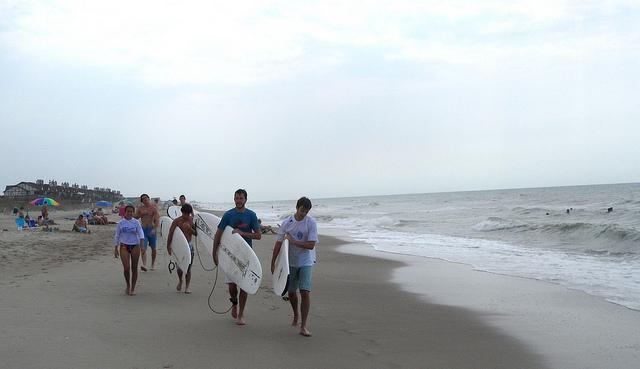How many people are there?
Give a very brief answer. 3. How many cars are shown?
Give a very brief answer. 0. 